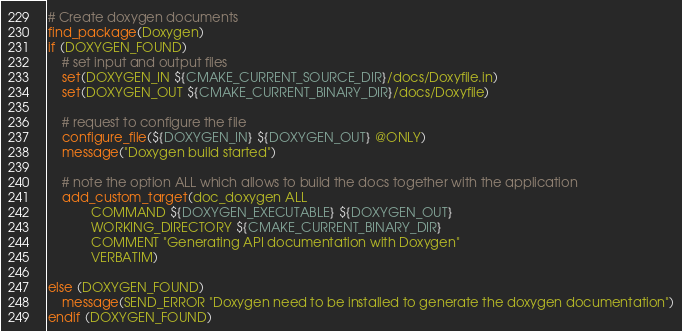<code> <loc_0><loc_0><loc_500><loc_500><_CMake_># Create doxygen documents
find_package(Doxygen)
if (DOXYGEN_FOUND)
    # set input and output files
    set(DOXYGEN_IN ${CMAKE_CURRENT_SOURCE_DIR}/docs/Doxyfile.in)
    set(DOXYGEN_OUT ${CMAKE_CURRENT_BINARY_DIR}/docs/Doxyfile)

    # request to configure the file
    configure_file(${DOXYGEN_IN} ${DOXYGEN_OUT} @ONLY)
    message("Doxygen build started")

    # note the option ALL which allows to build the docs together with the application
    add_custom_target(doc_doxygen ALL
            COMMAND ${DOXYGEN_EXECUTABLE} ${DOXYGEN_OUT}
            WORKING_DIRECTORY ${CMAKE_CURRENT_BINARY_DIR}
            COMMENT "Generating API documentation with Doxygen"
            VERBATIM)

else (DOXYGEN_FOUND)
    message(SEND_ERROR "Doxygen need to be installed to generate the doxygen documentation")
endif (DOXYGEN_FOUND)
</code> 